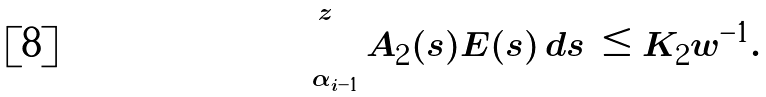Convert formula to latex. <formula><loc_0><loc_0><loc_500><loc_500>\left | \int _ { \alpha _ { i - 1 } } ^ { z } A _ { 2 } ( s ) E ( s ) \, d s \right | \leq K _ { 2 } w ^ { - 1 } .</formula> 